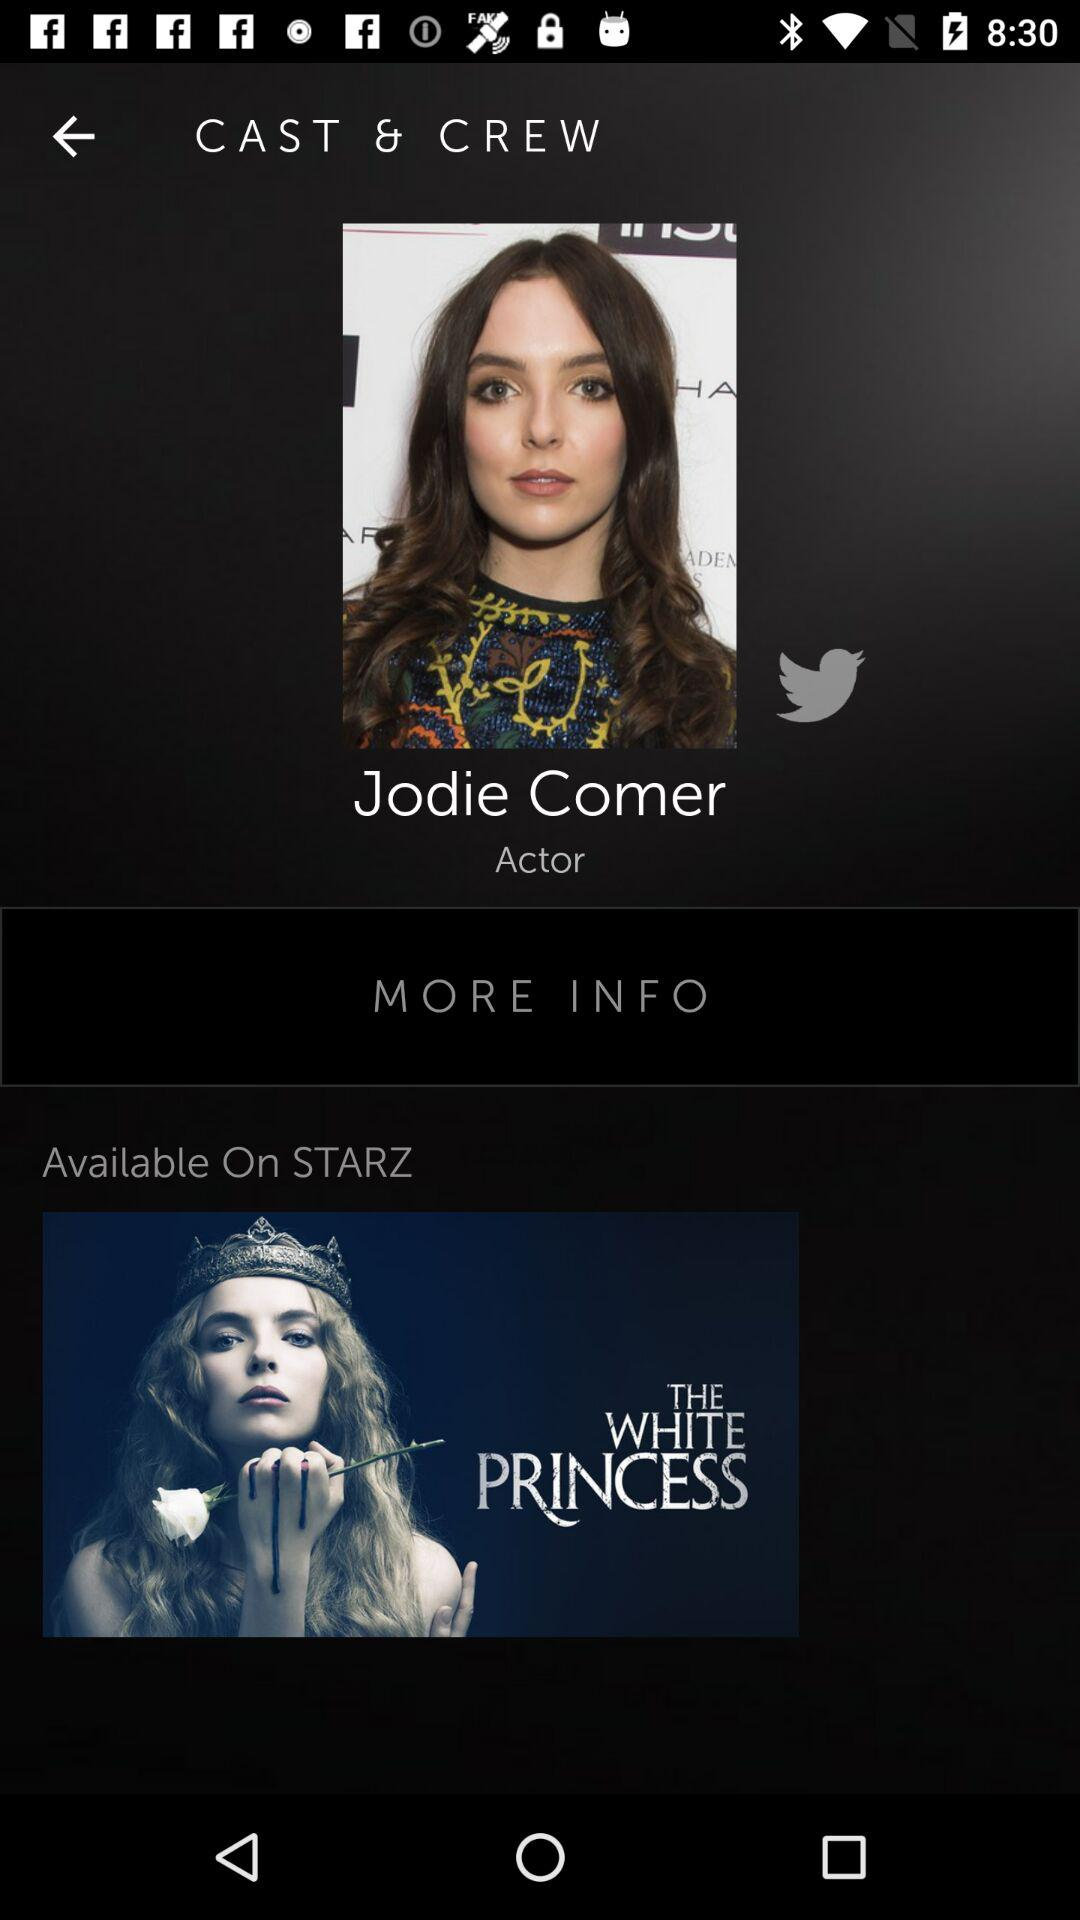Where is the movie available? The movie is available on "STARZ". 